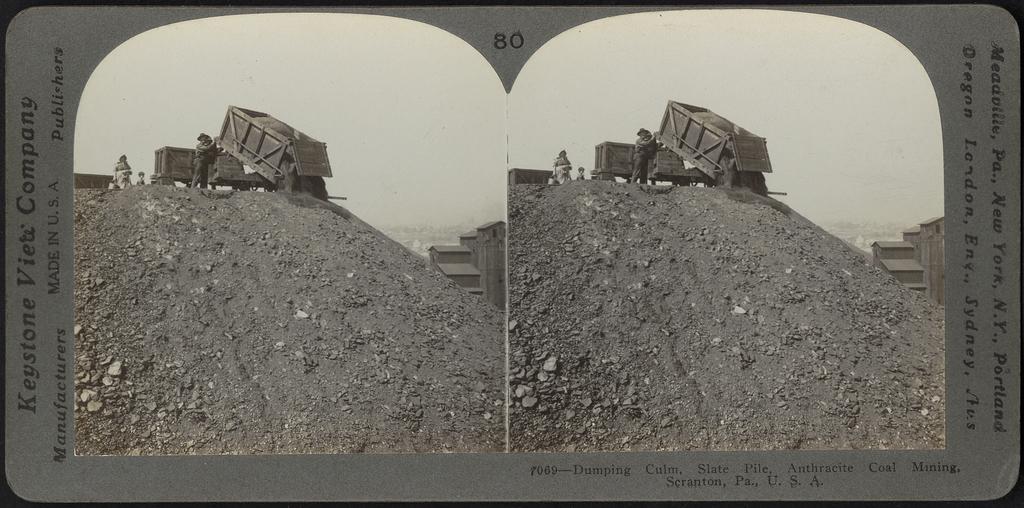What slide number is this?
Provide a succinct answer. 80. 